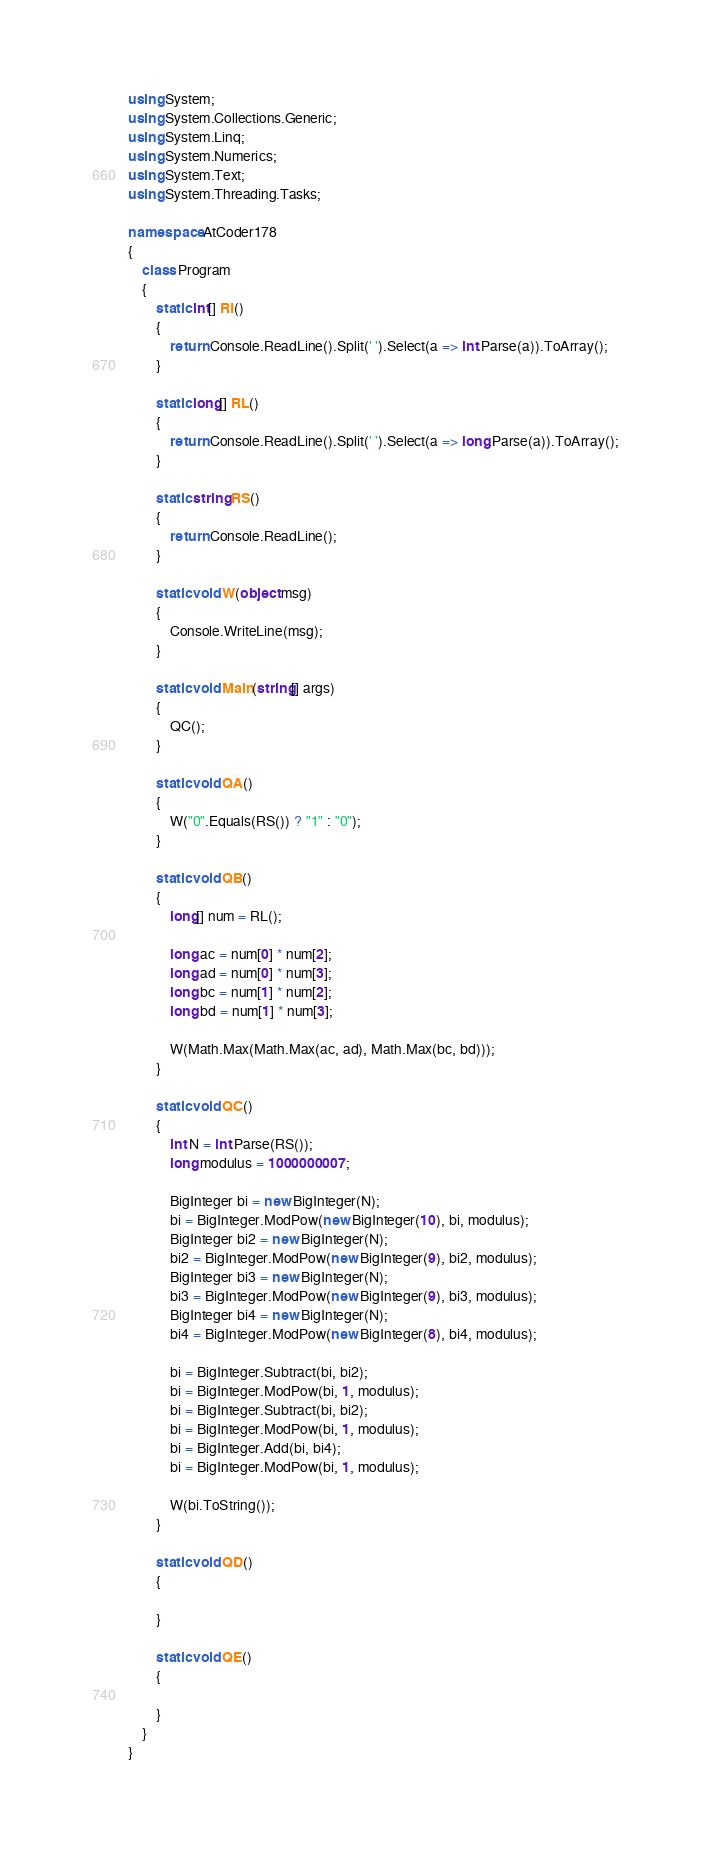<code> <loc_0><loc_0><loc_500><loc_500><_C#_>using System;
using System.Collections.Generic;
using System.Linq;
using System.Numerics;
using System.Text;
using System.Threading.Tasks;

namespace AtCoder178
{
    class Program
    {
        static int[] RI()
        {
            return Console.ReadLine().Split(' ').Select(a => int.Parse(a)).ToArray();
        }

        static long[] RL()
        {
            return Console.ReadLine().Split(' ').Select(a => long.Parse(a)).ToArray();
        }

        static string RS()
        {
            return Console.ReadLine();
        }

        static void W(object msg)
        {
            Console.WriteLine(msg);
        }

        static void Main(string[] args)
        {
            QC();
        }

        static void QA()
        {
            W("0".Equals(RS()) ? "1" : "0");
        }

        static void QB()
        {
            long[] num = RL();

            long ac = num[0] * num[2];
            long ad = num[0] * num[3];
            long bc = num[1] * num[2];
            long bd = num[1] * num[3];

            W(Math.Max(Math.Max(ac, ad), Math.Max(bc, bd)));
        }

        static void QC()
        {
            int N = int.Parse(RS());
            long modulus = 1000000007;

            BigInteger bi = new BigInteger(N);
            bi = BigInteger.ModPow(new BigInteger(10), bi, modulus);
            BigInteger bi2 = new BigInteger(N);
            bi2 = BigInteger.ModPow(new BigInteger(9), bi2, modulus);
            BigInteger bi3 = new BigInteger(N);
            bi3 = BigInteger.ModPow(new BigInteger(9), bi3, modulus);
            BigInteger bi4 = new BigInteger(N);
            bi4 = BigInteger.ModPow(new BigInteger(8), bi4, modulus);

            bi = BigInteger.Subtract(bi, bi2);
            bi = BigInteger.ModPow(bi, 1, modulus);
            bi = BigInteger.Subtract(bi, bi2);
            bi = BigInteger.ModPow(bi, 1, modulus);
            bi = BigInteger.Add(bi, bi4);
            bi = BigInteger.ModPow(bi, 1, modulus);

            W(bi.ToString());
        }

        static void QD()
        {

        }

        static void QE()
        {

        }
    }
}
</code> 